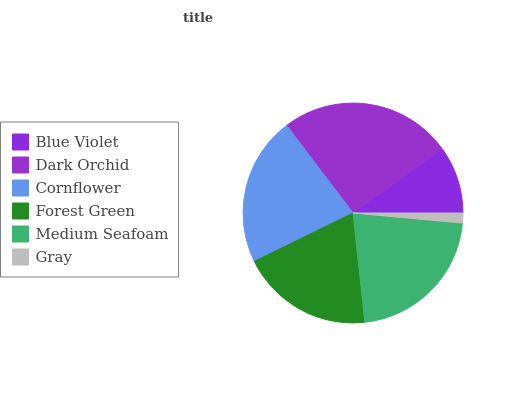Is Gray the minimum?
Answer yes or no. Yes. Is Dark Orchid the maximum?
Answer yes or no. Yes. Is Cornflower the minimum?
Answer yes or no. No. Is Cornflower the maximum?
Answer yes or no. No. Is Dark Orchid greater than Cornflower?
Answer yes or no. Yes. Is Cornflower less than Dark Orchid?
Answer yes or no. Yes. Is Cornflower greater than Dark Orchid?
Answer yes or no. No. Is Dark Orchid less than Cornflower?
Answer yes or no. No. Is Medium Seafoam the high median?
Answer yes or no. Yes. Is Forest Green the low median?
Answer yes or no. Yes. Is Blue Violet the high median?
Answer yes or no. No. Is Gray the low median?
Answer yes or no. No. 